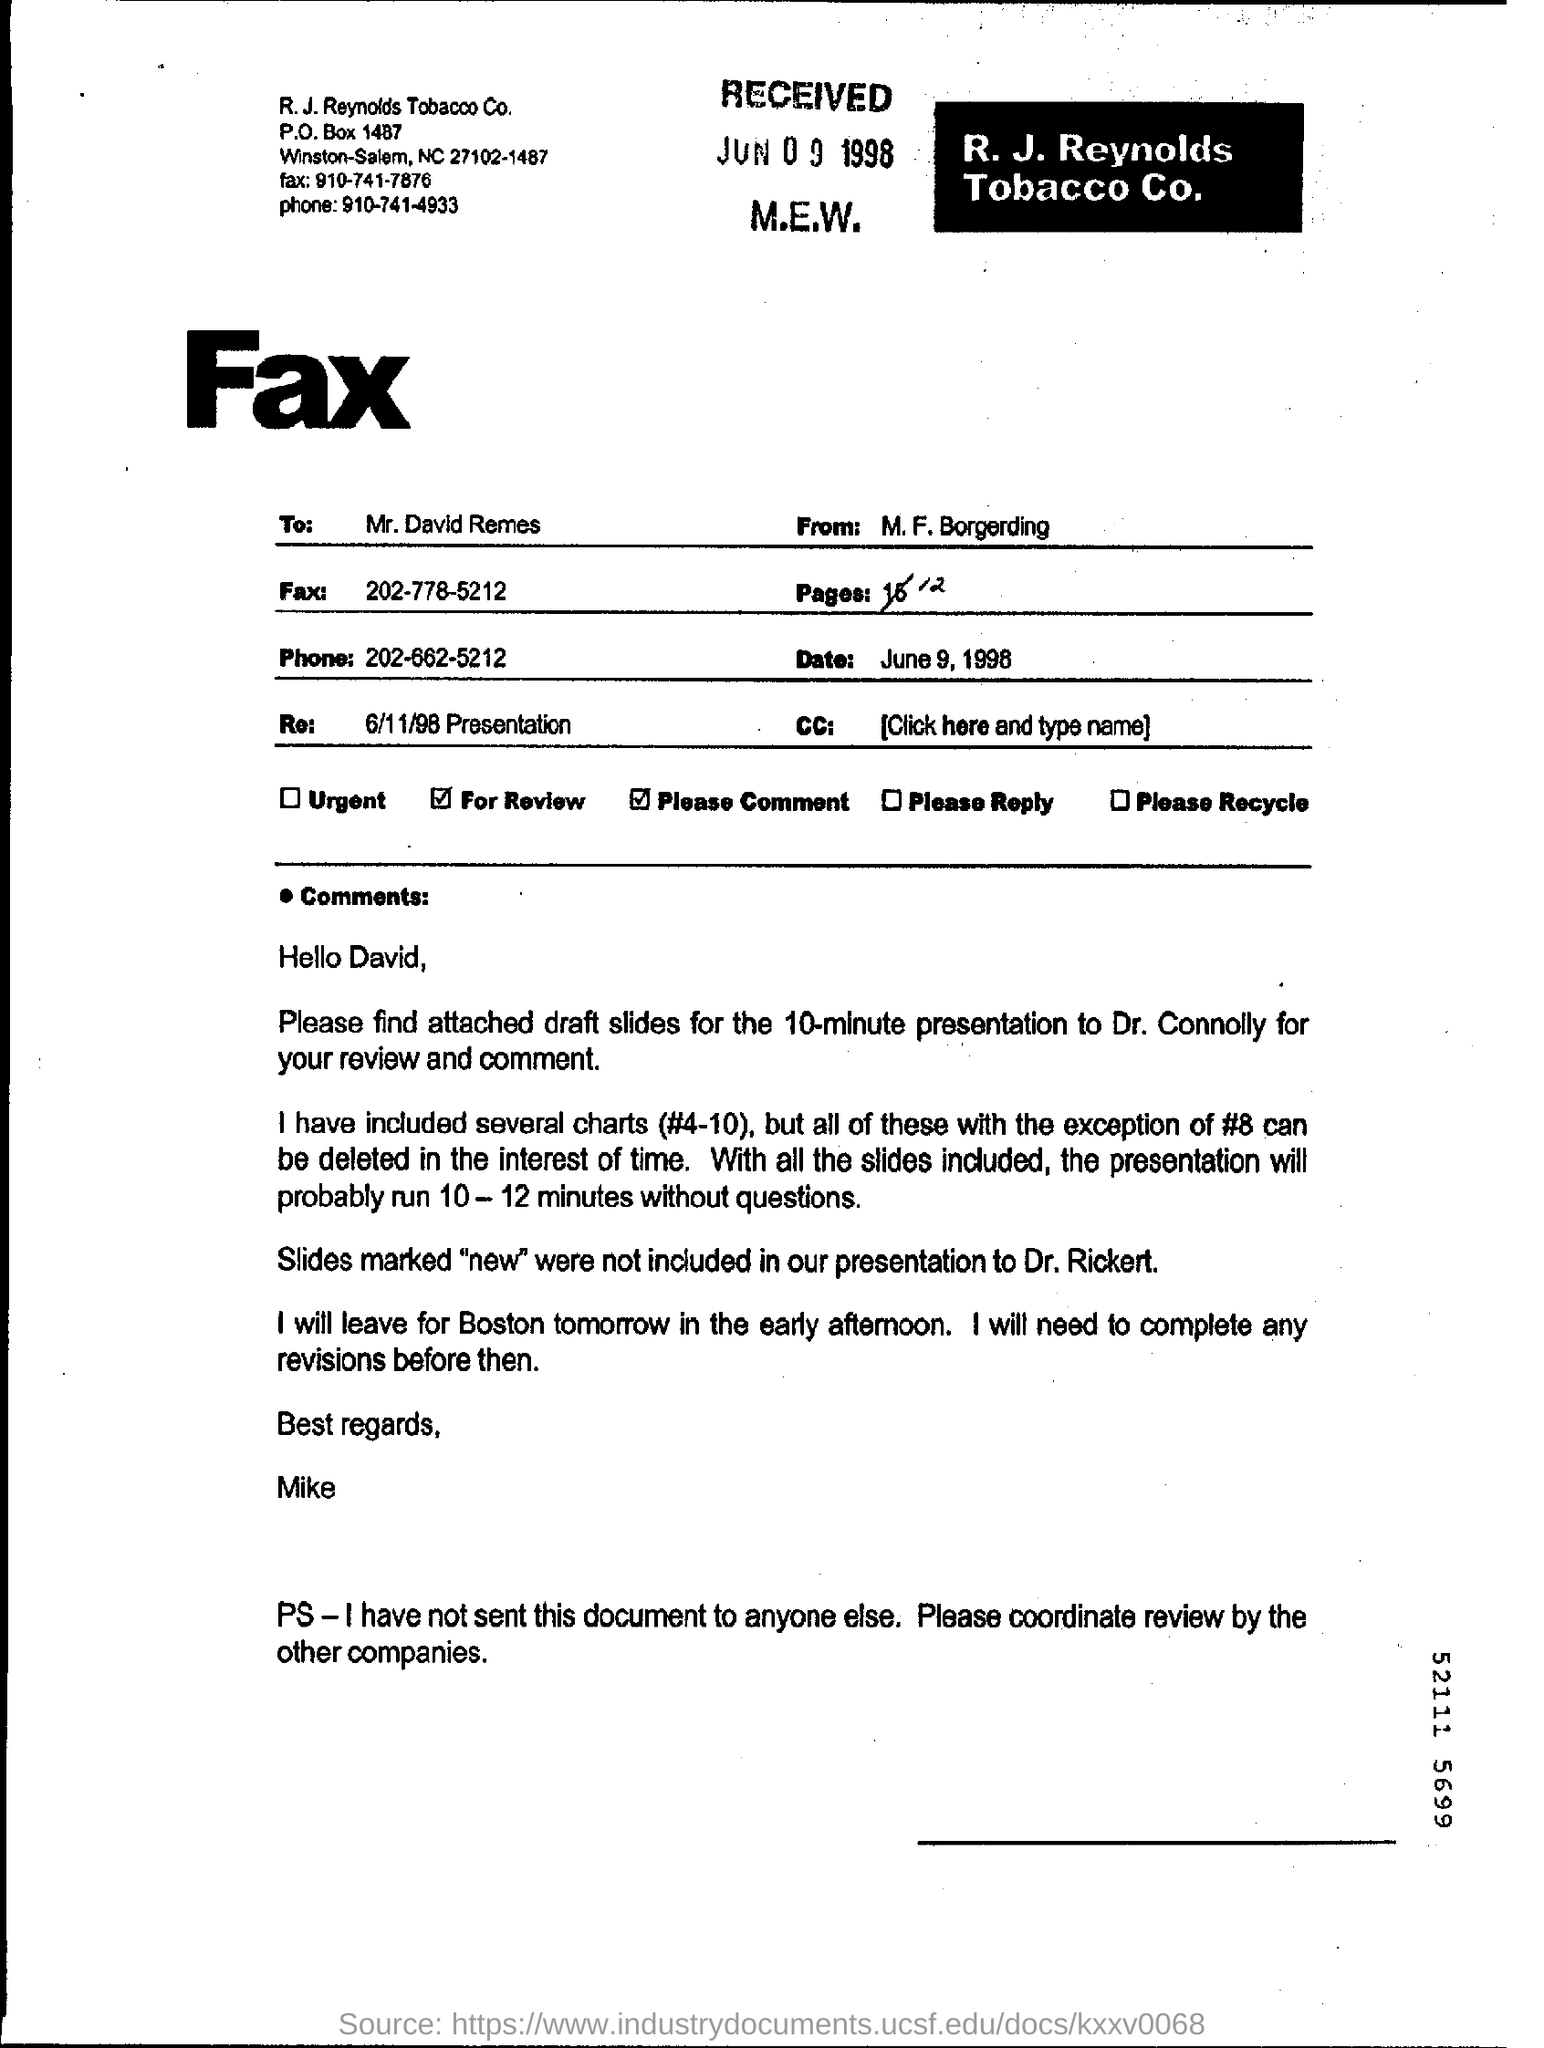Specify some key components in this picture. The document is addressed to Mr. David Remes. The receiver of this document is commonly referred to by the shortened version of their name, which is David. With big bold letters, the phrase 'Fax' is written. 